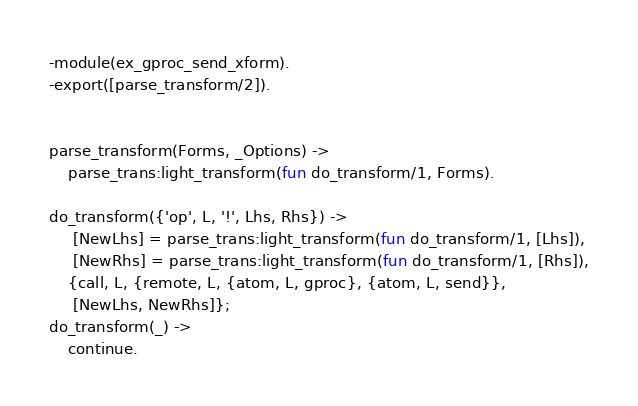Convert code to text. <code><loc_0><loc_0><loc_500><loc_500><_Erlang_>-module(ex_gproc_send_xform).
-export([parse_transform/2]).


parse_transform(Forms, _Options) ->
    parse_trans:light_transform(fun do_transform/1, Forms).

do_transform({'op', L, '!', Lhs, Rhs}) ->
     [NewLhs] = parse_trans:light_transform(fun do_transform/1, [Lhs]),
     [NewRhs] = parse_trans:light_transform(fun do_transform/1, [Rhs]),
    {call, L, {remote, L, {atom, L, gproc}, {atom, L, send}},
     [NewLhs, NewRhs]};
do_transform(_) ->
    continue.

</code> 